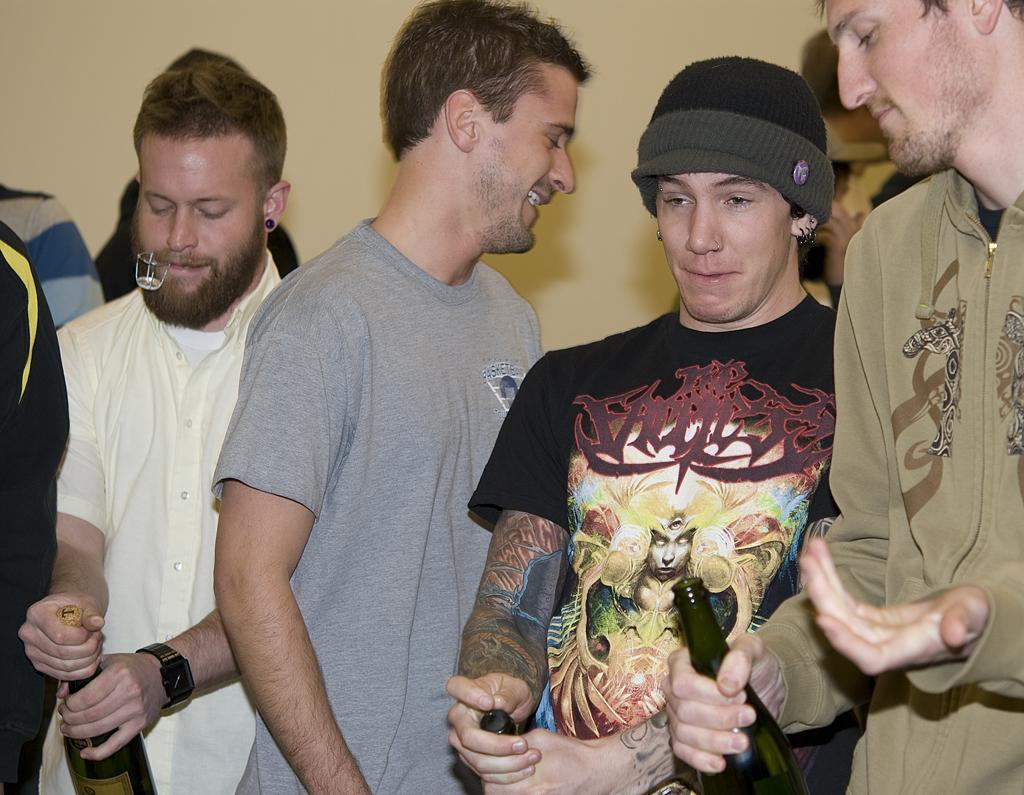Please provide a concise description of this image. On the right side a man is standing and holding a wine bottle. Beside him there is a person, this person wore black color t-shirt and a cap. On the left side there are 2 men. 